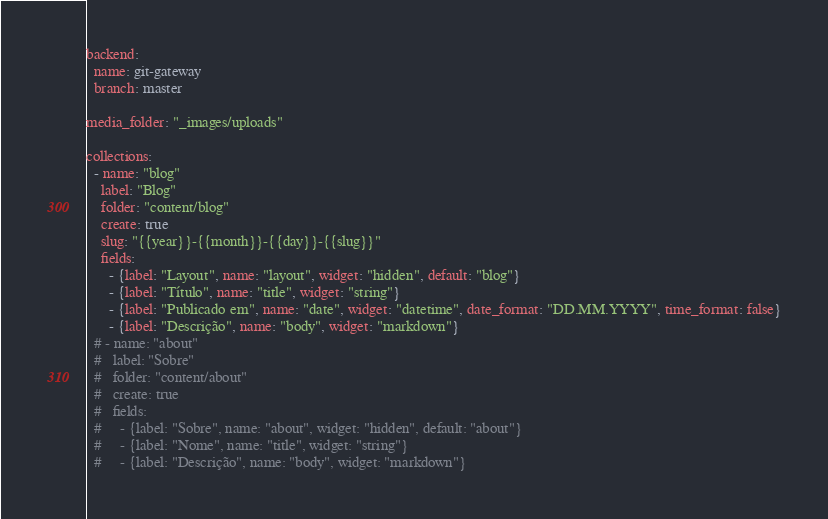Convert code to text. <code><loc_0><loc_0><loc_500><loc_500><_YAML_>backend:
  name: git-gateway
  branch: master

media_folder: "_images/uploads"

collections:
  - name: "blog"
    label: "Blog"
    folder: "content/blog"
    create: true
    slug: "{{year}}-{{month}}-{{day}}-{{slug}}"
    fields:
      - {label: "Layout", name: "layout", widget: "hidden", default: "blog"}
      - {label: "Título", name: "title", widget: "string"}
      - {label: "Publicado em", name: "date", widget: "datetime", date_format: "DD.MM.YYYY", time_format: false}
      - {label: "Descrição", name: "body", widget: "markdown"}
  # - name: "about"
  #   label: "Sobre"
  #   folder: "content/about"
  #   create: true
  #   fields:
  #     - {label: "Sobre", name: "about", widget: "hidden", default: "about"}
  #     - {label: "Nome", name: "title", widget: "string"}
  #     - {label: "Descrição", name: "body", widget: "markdown"}</code> 